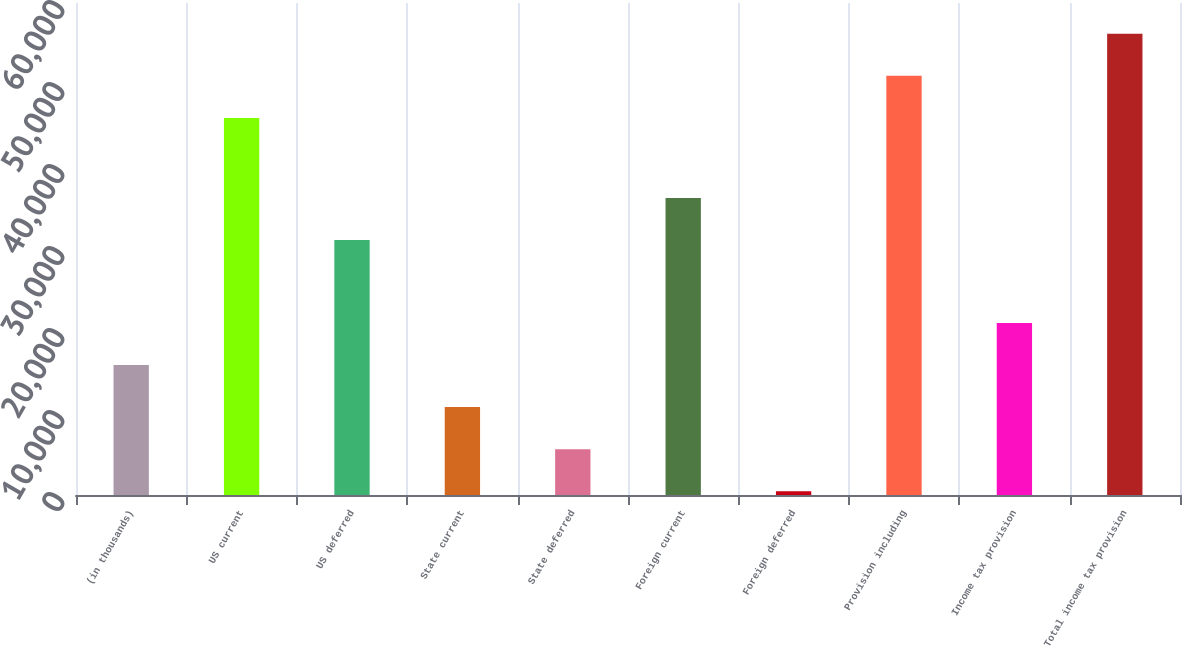Convert chart to OTSL. <chart><loc_0><loc_0><loc_500><loc_500><bar_chart><fcel>(in thousands)<fcel>US current<fcel>US deferred<fcel>State current<fcel>State deferred<fcel>Foreign current<fcel>Foreign deferred<fcel>Provision including<fcel>Income tax provision<fcel>Total income tax provision<nl><fcel>15846.8<fcel>45985<fcel>31087<fcel>10718.2<fcel>5589.6<fcel>36215.6<fcel>461<fcel>51113.6<fcel>20975.4<fcel>56242.2<nl></chart> 